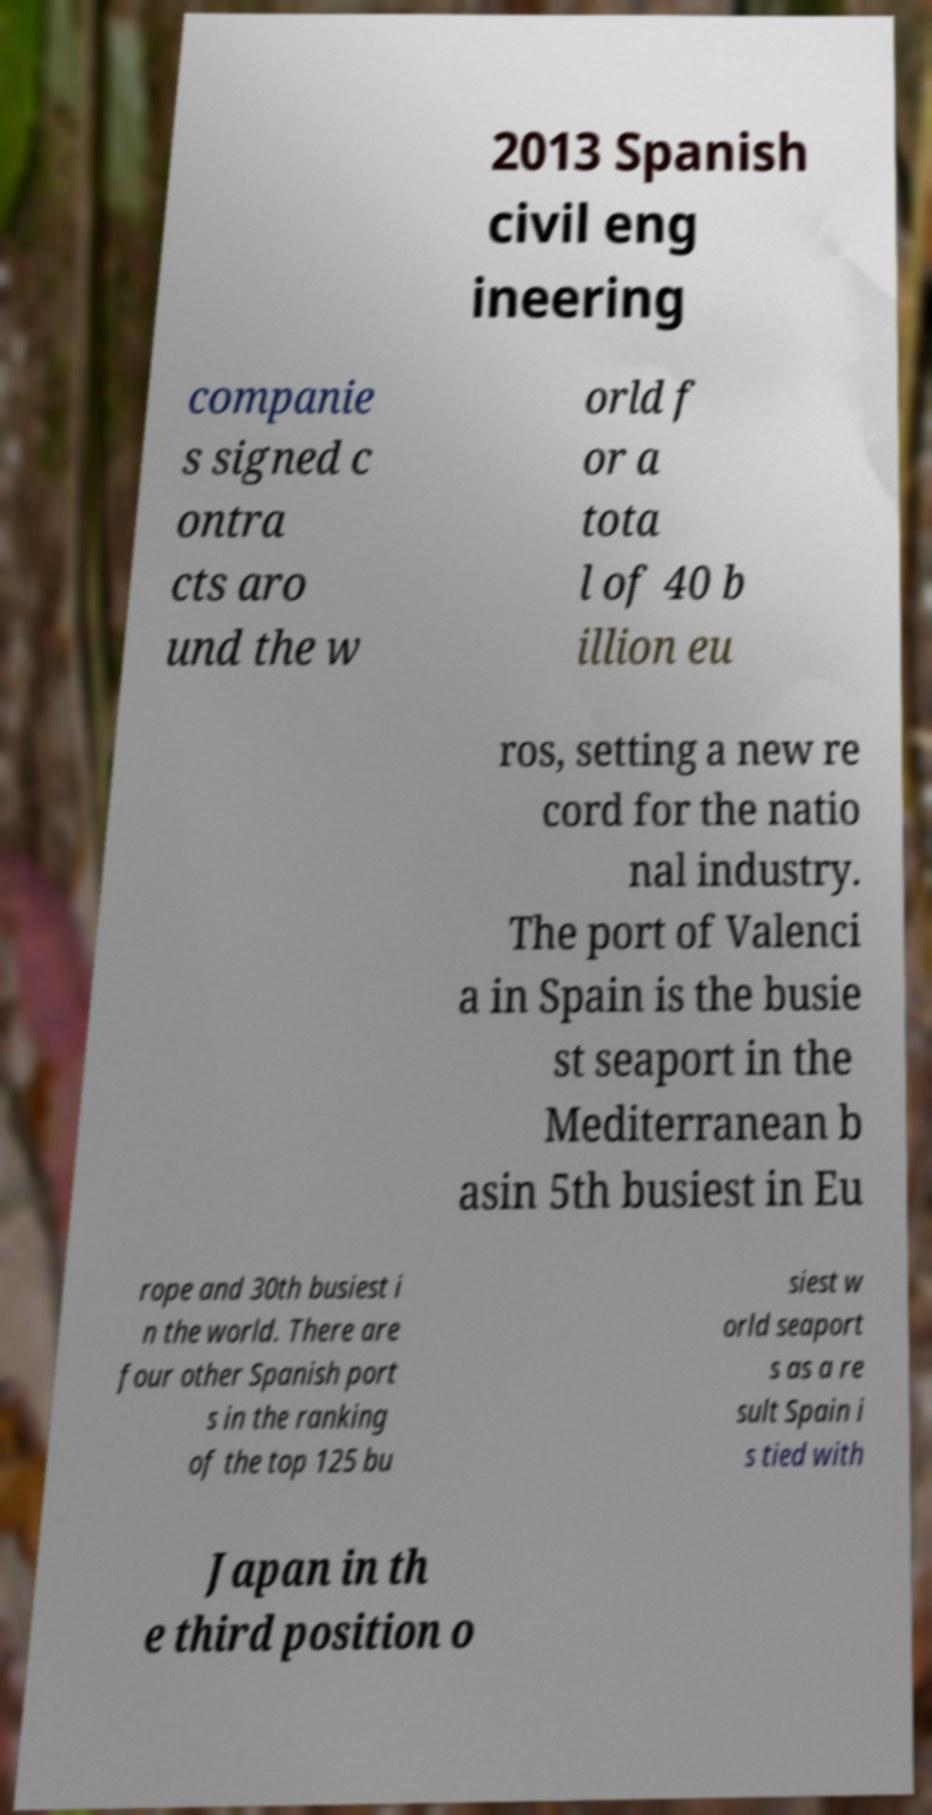For documentation purposes, I need the text within this image transcribed. Could you provide that? 2013 Spanish civil eng ineering companie s signed c ontra cts aro und the w orld f or a tota l of 40 b illion eu ros, setting a new re cord for the natio nal industry. The port of Valenci a in Spain is the busie st seaport in the Mediterranean b asin 5th busiest in Eu rope and 30th busiest i n the world. There are four other Spanish port s in the ranking of the top 125 bu siest w orld seaport s as a re sult Spain i s tied with Japan in th e third position o 